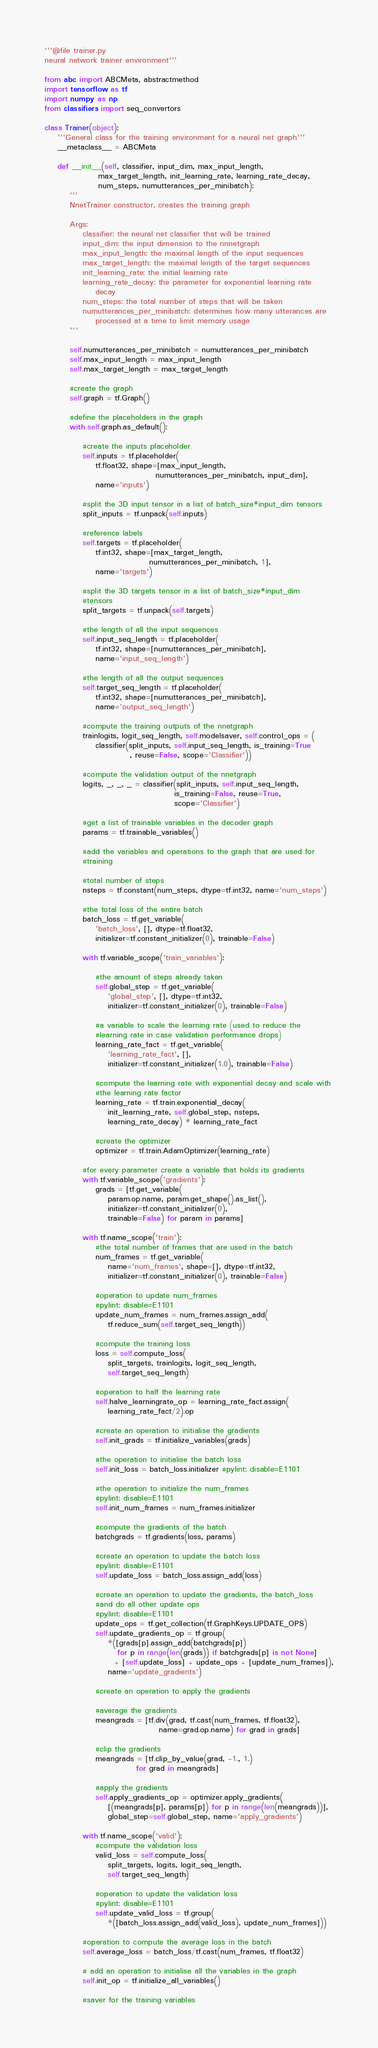Convert code to text. <code><loc_0><loc_0><loc_500><loc_500><_Python_>'''@file trainer.py
neural network trainer environment'''

from abc import ABCMeta, abstractmethod
import tensorflow as tf
import numpy as np
from classifiers import seq_convertors

class Trainer(object):
    '''General class for the training environment for a neural net graph'''
    __metaclass__ = ABCMeta

    def __init__(self, classifier, input_dim, max_input_length,
                 max_target_length, init_learning_rate, learning_rate_decay,
                 num_steps, numutterances_per_minibatch):
        '''
        NnetTrainer constructor, creates the training graph

        Args:
            classifier: the neural net classifier that will be trained
            input_dim: the input dimension to the nnnetgraph
            max_input_length: the maximal length of the input sequences
            max_target_length: the maximal length of the target sequences
            init_learning_rate: the initial learning rate
            learning_rate_decay: the parameter for exponential learning rate
                decay
            num_steps: the total number of steps that will be taken
            numutterances_per_minibatch: determines how many utterances are
                processed at a time to limit memory usage
        '''

        self.numutterances_per_minibatch = numutterances_per_minibatch
        self.max_input_length = max_input_length
        self.max_target_length = max_target_length

        #create the graph
        self.graph = tf.Graph()

        #define the placeholders in the graph
        with self.graph.as_default():

            #create the inputs placeholder
            self.inputs = tf.placeholder(
                tf.float32, shape=[max_input_length,
                                   numutterances_per_minibatch, input_dim],
                name='inputs')

            #split the 3D input tensor in a list of batch_size*input_dim tensors
            split_inputs = tf.unpack(self.inputs)

            #reference labels
            self.targets = tf.placeholder(
                tf.int32, shape=[max_target_length,
                                 numutterances_per_minibatch, 1],
                name='targets')

            #split the 3D targets tensor in a list of batch_size*input_dim
            #tensors
            split_targets = tf.unpack(self.targets)

            #the length of all the input sequences
            self.input_seq_length = tf.placeholder(
                tf.int32, shape=[numutterances_per_minibatch],
                name='input_seq_length')

            #the length of all the output sequences
            self.target_seq_length = tf.placeholder(
                tf.int32, shape=[numutterances_per_minibatch],
                name='output_seq_length')

            #compute the training outputs of the nnetgraph
            trainlogits, logit_seq_length, self.modelsaver, self.control_ops = (
                classifier(split_inputs, self.input_seq_length, is_training=True
                           , reuse=False, scope='Classifier'))

            #compute the validation output of the nnetgraph
            logits, _, _, _ = classifier(split_inputs, self.input_seq_length,
                                         is_training=False, reuse=True,
                                         scope='Classifier')

            #get a list of trainable variables in the decoder graph
            params = tf.trainable_variables()

            #add the variables and operations to the graph that are used for
            #training

            #total number of steps
            nsteps = tf.constant(num_steps, dtype=tf.int32, name='num_steps')

            #the total loss of the entire batch
            batch_loss = tf.get_variable(
                'batch_loss', [], dtype=tf.float32,
                initializer=tf.constant_initializer(0), trainable=False)

            with tf.variable_scope('train_variables'):

                #the amount of steps already taken
                self.global_step = tf.get_variable(
                    'global_step', [], dtype=tf.int32,
                    initializer=tf.constant_initializer(0), trainable=False)

                #a variable to scale the learning rate (used to reduce the
                #learning rate in case validation performance drops)
                learning_rate_fact = tf.get_variable(
                    'learning_rate_fact', [],
                    initializer=tf.constant_initializer(1.0), trainable=False)

                #compute the learning rate with exponential decay and scale with
                #the learning rate factor
                learning_rate = tf.train.exponential_decay(
                    init_learning_rate, self.global_step, nsteps,
                    learning_rate_decay) * learning_rate_fact

                #create the optimizer
                optimizer = tf.train.AdamOptimizer(learning_rate)

            #for every parameter create a variable that holds its gradients
            with tf.variable_scope('gradients'):
                grads = [tf.get_variable(
                    param.op.name, param.get_shape().as_list(),
                    initializer=tf.constant_initializer(0),
                    trainable=False) for param in params]

            with tf.name_scope('train'):
                #the total number of frames that are used in the batch
                num_frames = tf.get_variable(
                    name='num_frames', shape=[], dtype=tf.int32,
                    initializer=tf.constant_initializer(0), trainable=False)

                #operation to update num_frames
                #pylint: disable=E1101
                update_num_frames = num_frames.assign_add(
                    tf.reduce_sum(self.target_seq_length))

                #compute the training loss
                loss = self.compute_loss(
                    split_targets, trainlogits, logit_seq_length,
                    self.target_seq_length)

                #operation to half the learning rate
                self.halve_learningrate_op = learning_rate_fact.assign(
                    learning_rate_fact/2).op

                #create an operation to initialise the gradients
                self.init_grads = tf.initialize_variables(grads)

                #the operation to initialise the batch loss
                self.init_loss = batch_loss.initializer #pylint: disable=E1101

                #the operation to initialize the num_frames
                #pylint: disable=E1101
                self.init_num_frames = num_frames.initializer

                #compute the gradients of the batch
                batchgrads = tf.gradients(loss, params)

                #create an operation to update the batch loss
                #pylint: disable=E1101
                self.update_loss = batch_loss.assign_add(loss)

                #create an operation to update the gradients, the batch_loss
                #and do all other update ops
                #pylint: disable=E1101
                update_ops = tf.get_collection(tf.GraphKeys.UPDATE_OPS)
                self.update_gradients_op = tf.group(
                    *([grads[p].assign_add(batchgrads[p])
                       for p in range(len(grads)) if batchgrads[p] is not None]
                      + [self.update_loss] + update_ops + [update_num_frames]),
                    name='update_gradients')

                #create an operation to apply the gradients

                #average the gradients
                meangrads = [tf.div(grad, tf.cast(num_frames, tf.float32),
                                    name=grad.op.name) for grad in grads]

                #clip the gradients
                meangrads = [tf.clip_by_value(grad, -1., 1.)
                             for grad in meangrads]

                #apply the gradients
                self.apply_gradients_op = optimizer.apply_gradients(
                    [(meangrads[p], params[p]) for p in range(len(meangrads))],
                    global_step=self.global_step, name='apply_gradients')

            with tf.name_scope('valid'):
                #compute the validation loss
                valid_loss = self.compute_loss(
                    split_targets, logits, logit_seq_length,
                    self.target_seq_length)

                #operation to update the validation loss
                #pylint: disable=E1101
                self.update_valid_loss = tf.group(
                    *([batch_loss.assign_add(valid_loss), update_num_frames]))

            #operation to compute the average loss in the batch
            self.average_loss = batch_loss/tf.cast(num_frames, tf.float32)

            # add an operation to initialise all the variables in the graph
            self.init_op = tf.initialize_all_variables()

            #saver for the training variables</code> 